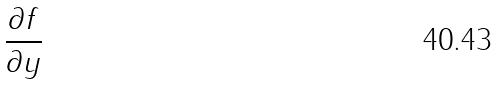Convert formula to latex. <formula><loc_0><loc_0><loc_500><loc_500>\frac { \partial f } { \partial y }</formula> 